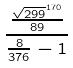Convert formula to latex. <formula><loc_0><loc_0><loc_500><loc_500>\frac { \frac { \sqrt { 2 9 9 } ^ { 1 7 0 } } { 8 9 } } { \frac { 8 } { 3 7 6 } - 1 }</formula> 